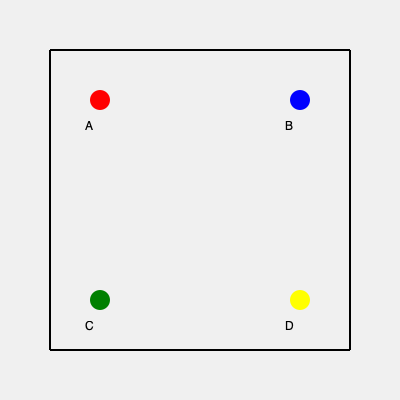As part of a tourism improvement initiative, you need to match four key landmarks to their correct positions on a simplified city map. The landmarks are: City Hall, Central Park, Museum of Art, and Historical Monument. Given that the City Hall is located at point A, which landmark is most likely represented by point C? To solve this problem, we need to consider the typical layout of a city and the relative positions of major landmarks:

1. We know that City Hall is at point A, which is in the upper-left quadrant of the map.

2. City halls are often centrally located, but tend to be closer to the historical or downtown areas of a city.

3. Central parks are typically large, centrally located areas. On this map, the most central position would be somewhere in the middle, but since we don't have a central point, it's likely to be at point B or D.

4. Museums of Art are often located near central areas or parks, but not necessarily in the heart of downtown. They could be at point B or D.

5. Historical monuments are frequently found in older parts of the city, often near city halls or in downtown areas.

6. Point C is in the lower-left quadrant, which is diagonal to City Hall. This position suggests it might be further from the city center.

7. Given these considerations, the Historical Monument is most likely to be near City Hall in an older part of the city, while Central Park and the Museum of Art would occupy more central or upper-right positions.

Therefore, by process of elimination and considering typical city layouts, point C is most likely to represent the Museum of Art.
Answer: Museum of Art 